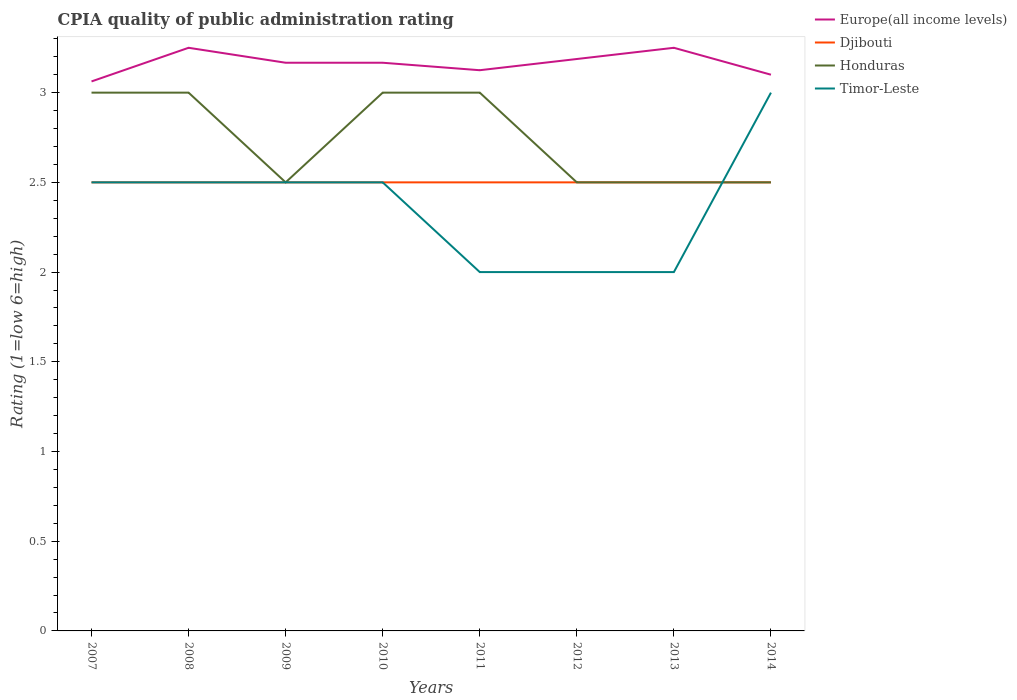How many different coloured lines are there?
Your response must be concise. 4. Is the number of lines equal to the number of legend labels?
Offer a terse response. Yes. Across all years, what is the maximum CPIA rating in Europe(all income levels)?
Offer a very short reply. 3.06. What is the difference between the highest and the second highest CPIA rating in Timor-Leste?
Offer a very short reply. 1. What is the difference between the highest and the lowest CPIA rating in Europe(all income levels)?
Make the answer very short. 5. Is the CPIA rating in Timor-Leste strictly greater than the CPIA rating in Europe(all income levels) over the years?
Offer a very short reply. Yes. How many lines are there?
Give a very brief answer. 4. How many years are there in the graph?
Provide a short and direct response. 8. What is the difference between two consecutive major ticks on the Y-axis?
Offer a very short reply. 0.5. Does the graph contain any zero values?
Make the answer very short. No. Does the graph contain grids?
Provide a succinct answer. No. How are the legend labels stacked?
Offer a terse response. Vertical. What is the title of the graph?
Make the answer very short. CPIA quality of public administration rating. What is the label or title of the X-axis?
Your response must be concise. Years. What is the Rating (1=low 6=high) in Europe(all income levels) in 2007?
Offer a very short reply. 3.06. What is the Rating (1=low 6=high) in Djibouti in 2007?
Ensure brevity in your answer.  2.5. What is the Rating (1=low 6=high) of Honduras in 2007?
Give a very brief answer. 3. What is the Rating (1=low 6=high) in Timor-Leste in 2007?
Your answer should be very brief. 2.5. What is the Rating (1=low 6=high) in Djibouti in 2008?
Provide a succinct answer. 2.5. What is the Rating (1=low 6=high) of Honduras in 2008?
Offer a very short reply. 3. What is the Rating (1=low 6=high) of Europe(all income levels) in 2009?
Ensure brevity in your answer.  3.17. What is the Rating (1=low 6=high) in Djibouti in 2009?
Your response must be concise. 2.5. What is the Rating (1=low 6=high) of Europe(all income levels) in 2010?
Your response must be concise. 3.17. What is the Rating (1=low 6=high) of Honduras in 2010?
Your answer should be very brief. 3. What is the Rating (1=low 6=high) of Timor-Leste in 2010?
Provide a succinct answer. 2.5. What is the Rating (1=low 6=high) in Europe(all income levels) in 2011?
Your answer should be very brief. 3.12. What is the Rating (1=low 6=high) of Djibouti in 2011?
Your response must be concise. 2.5. What is the Rating (1=low 6=high) of Honduras in 2011?
Provide a succinct answer. 3. What is the Rating (1=low 6=high) in Timor-Leste in 2011?
Give a very brief answer. 2. What is the Rating (1=low 6=high) of Europe(all income levels) in 2012?
Your answer should be compact. 3.19. What is the Rating (1=low 6=high) in Djibouti in 2012?
Offer a terse response. 2.5. What is the Rating (1=low 6=high) in Timor-Leste in 2014?
Your answer should be compact. 3. Across all years, what is the maximum Rating (1=low 6=high) of Djibouti?
Your response must be concise. 2.5. Across all years, what is the maximum Rating (1=low 6=high) in Timor-Leste?
Give a very brief answer. 3. Across all years, what is the minimum Rating (1=low 6=high) in Europe(all income levels)?
Your answer should be very brief. 3.06. Across all years, what is the minimum Rating (1=low 6=high) of Djibouti?
Your response must be concise. 2.5. Across all years, what is the minimum Rating (1=low 6=high) of Honduras?
Give a very brief answer. 2.5. Across all years, what is the minimum Rating (1=low 6=high) of Timor-Leste?
Your answer should be compact. 2. What is the total Rating (1=low 6=high) in Europe(all income levels) in the graph?
Offer a terse response. 25.31. What is the difference between the Rating (1=low 6=high) in Europe(all income levels) in 2007 and that in 2008?
Give a very brief answer. -0.19. What is the difference between the Rating (1=low 6=high) in Honduras in 2007 and that in 2008?
Give a very brief answer. 0. What is the difference between the Rating (1=low 6=high) of Timor-Leste in 2007 and that in 2008?
Your answer should be very brief. 0. What is the difference between the Rating (1=low 6=high) of Europe(all income levels) in 2007 and that in 2009?
Offer a terse response. -0.1. What is the difference between the Rating (1=low 6=high) of Djibouti in 2007 and that in 2009?
Keep it short and to the point. 0. What is the difference between the Rating (1=low 6=high) in Timor-Leste in 2007 and that in 2009?
Provide a short and direct response. 0. What is the difference between the Rating (1=low 6=high) in Europe(all income levels) in 2007 and that in 2010?
Offer a terse response. -0.1. What is the difference between the Rating (1=low 6=high) in Europe(all income levels) in 2007 and that in 2011?
Your response must be concise. -0.06. What is the difference between the Rating (1=low 6=high) in Europe(all income levels) in 2007 and that in 2012?
Your answer should be very brief. -0.12. What is the difference between the Rating (1=low 6=high) of Djibouti in 2007 and that in 2012?
Ensure brevity in your answer.  0. What is the difference between the Rating (1=low 6=high) in Europe(all income levels) in 2007 and that in 2013?
Offer a very short reply. -0.19. What is the difference between the Rating (1=low 6=high) in Timor-Leste in 2007 and that in 2013?
Your response must be concise. 0.5. What is the difference between the Rating (1=low 6=high) in Europe(all income levels) in 2007 and that in 2014?
Give a very brief answer. -0.04. What is the difference between the Rating (1=low 6=high) of Timor-Leste in 2007 and that in 2014?
Provide a succinct answer. -0.5. What is the difference between the Rating (1=low 6=high) of Europe(all income levels) in 2008 and that in 2009?
Offer a terse response. 0.08. What is the difference between the Rating (1=low 6=high) of Honduras in 2008 and that in 2009?
Provide a short and direct response. 0.5. What is the difference between the Rating (1=low 6=high) of Europe(all income levels) in 2008 and that in 2010?
Provide a succinct answer. 0.08. What is the difference between the Rating (1=low 6=high) in Honduras in 2008 and that in 2010?
Your answer should be very brief. 0. What is the difference between the Rating (1=low 6=high) of Timor-Leste in 2008 and that in 2010?
Offer a terse response. 0. What is the difference between the Rating (1=low 6=high) of Europe(all income levels) in 2008 and that in 2011?
Ensure brevity in your answer.  0.12. What is the difference between the Rating (1=low 6=high) in Europe(all income levels) in 2008 and that in 2012?
Offer a very short reply. 0.06. What is the difference between the Rating (1=low 6=high) of Honduras in 2008 and that in 2012?
Make the answer very short. 0.5. What is the difference between the Rating (1=low 6=high) in Timor-Leste in 2008 and that in 2012?
Keep it short and to the point. 0.5. What is the difference between the Rating (1=low 6=high) in Europe(all income levels) in 2008 and that in 2013?
Provide a succinct answer. 0. What is the difference between the Rating (1=low 6=high) of Djibouti in 2008 and that in 2014?
Your response must be concise. 0. What is the difference between the Rating (1=low 6=high) in Honduras in 2008 and that in 2014?
Your answer should be compact. 0.5. What is the difference between the Rating (1=low 6=high) in Honduras in 2009 and that in 2010?
Keep it short and to the point. -0.5. What is the difference between the Rating (1=low 6=high) of Europe(all income levels) in 2009 and that in 2011?
Give a very brief answer. 0.04. What is the difference between the Rating (1=low 6=high) of Honduras in 2009 and that in 2011?
Offer a very short reply. -0.5. What is the difference between the Rating (1=low 6=high) of Timor-Leste in 2009 and that in 2011?
Provide a succinct answer. 0.5. What is the difference between the Rating (1=low 6=high) in Europe(all income levels) in 2009 and that in 2012?
Provide a short and direct response. -0.02. What is the difference between the Rating (1=low 6=high) of Timor-Leste in 2009 and that in 2012?
Give a very brief answer. 0.5. What is the difference between the Rating (1=low 6=high) in Europe(all income levels) in 2009 and that in 2013?
Offer a terse response. -0.08. What is the difference between the Rating (1=low 6=high) of Timor-Leste in 2009 and that in 2013?
Offer a very short reply. 0.5. What is the difference between the Rating (1=low 6=high) in Europe(all income levels) in 2009 and that in 2014?
Give a very brief answer. 0.07. What is the difference between the Rating (1=low 6=high) in Djibouti in 2009 and that in 2014?
Offer a terse response. 0. What is the difference between the Rating (1=low 6=high) of Europe(all income levels) in 2010 and that in 2011?
Provide a short and direct response. 0.04. What is the difference between the Rating (1=low 6=high) in Honduras in 2010 and that in 2011?
Your answer should be very brief. 0. What is the difference between the Rating (1=low 6=high) in Timor-Leste in 2010 and that in 2011?
Keep it short and to the point. 0.5. What is the difference between the Rating (1=low 6=high) in Europe(all income levels) in 2010 and that in 2012?
Your answer should be compact. -0.02. What is the difference between the Rating (1=low 6=high) of Djibouti in 2010 and that in 2012?
Provide a short and direct response. 0. What is the difference between the Rating (1=low 6=high) in Europe(all income levels) in 2010 and that in 2013?
Keep it short and to the point. -0.08. What is the difference between the Rating (1=low 6=high) in Djibouti in 2010 and that in 2013?
Your answer should be very brief. 0. What is the difference between the Rating (1=low 6=high) of Honduras in 2010 and that in 2013?
Your answer should be very brief. 0.5. What is the difference between the Rating (1=low 6=high) in Europe(all income levels) in 2010 and that in 2014?
Your answer should be compact. 0.07. What is the difference between the Rating (1=low 6=high) of Djibouti in 2010 and that in 2014?
Your answer should be very brief. 0. What is the difference between the Rating (1=low 6=high) in Timor-Leste in 2010 and that in 2014?
Give a very brief answer. -0.5. What is the difference between the Rating (1=low 6=high) of Europe(all income levels) in 2011 and that in 2012?
Provide a short and direct response. -0.06. What is the difference between the Rating (1=low 6=high) of Djibouti in 2011 and that in 2012?
Your response must be concise. 0. What is the difference between the Rating (1=low 6=high) in Timor-Leste in 2011 and that in 2012?
Your response must be concise. 0. What is the difference between the Rating (1=low 6=high) of Europe(all income levels) in 2011 and that in 2013?
Your answer should be compact. -0.12. What is the difference between the Rating (1=low 6=high) in Timor-Leste in 2011 and that in 2013?
Your answer should be very brief. 0. What is the difference between the Rating (1=low 6=high) in Europe(all income levels) in 2011 and that in 2014?
Offer a very short reply. 0.03. What is the difference between the Rating (1=low 6=high) in Djibouti in 2011 and that in 2014?
Your answer should be compact. 0. What is the difference between the Rating (1=low 6=high) of Honduras in 2011 and that in 2014?
Your answer should be compact. 0.5. What is the difference between the Rating (1=low 6=high) of Timor-Leste in 2011 and that in 2014?
Keep it short and to the point. -1. What is the difference between the Rating (1=low 6=high) of Europe(all income levels) in 2012 and that in 2013?
Give a very brief answer. -0.06. What is the difference between the Rating (1=low 6=high) of Timor-Leste in 2012 and that in 2013?
Keep it short and to the point. 0. What is the difference between the Rating (1=low 6=high) in Europe(all income levels) in 2012 and that in 2014?
Provide a succinct answer. 0.09. What is the difference between the Rating (1=low 6=high) of Djibouti in 2012 and that in 2014?
Give a very brief answer. 0. What is the difference between the Rating (1=low 6=high) of Honduras in 2013 and that in 2014?
Ensure brevity in your answer.  0. What is the difference between the Rating (1=low 6=high) of Timor-Leste in 2013 and that in 2014?
Your response must be concise. -1. What is the difference between the Rating (1=low 6=high) of Europe(all income levels) in 2007 and the Rating (1=low 6=high) of Djibouti in 2008?
Provide a short and direct response. 0.56. What is the difference between the Rating (1=low 6=high) in Europe(all income levels) in 2007 and the Rating (1=low 6=high) in Honduras in 2008?
Ensure brevity in your answer.  0.06. What is the difference between the Rating (1=low 6=high) of Europe(all income levels) in 2007 and the Rating (1=low 6=high) of Timor-Leste in 2008?
Offer a terse response. 0.56. What is the difference between the Rating (1=low 6=high) of Honduras in 2007 and the Rating (1=low 6=high) of Timor-Leste in 2008?
Offer a terse response. 0.5. What is the difference between the Rating (1=low 6=high) in Europe(all income levels) in 2007 and the Rating (1=low 6=high) in Djibouti in 2009?
Offer a very short reply. 0.56. What is the difference between the Rating (1=low 6=high) of Europe(all income levels) in 2007 and the Rating (1=low 6=high) of Honduras in 2009?
Your answer should be compact. 0.56. What is the difference between the Rating (1=low 6=high) of Europe(all income levels) in 2007 and the Rating (1=low 6=high) of Timor-Leste in 2009?
Keep it short and to the point. 0.56. What is the difference between the Rating (1=low 6=high) in Honduras in 2007 and the Rating (1=low 6=high) in Timor-Leste in 2009?
Offer a terse response. 0.5. What is the difference between the Rating (1=low 6=high) of Europe(all income levels) in 2007 and the Rating (1=low 6=high) of Djibouti in 2010?
Offer a terse response. 0.56. What is the difference between the Rating (1=low 6=high) of Europe(all income levels) in 2007 and the Rating (1=low 6=high) of Honduras in 2010?
Give a very brief answer. 0.06. What is the difference between the Rating (1=low 6=high) in Europe(all income levels) in 2007 and the Rating (1=low 6=high) in Timor-Leste in 2010?
Offer a very short reply. 0.56. What is the difference between the Rating (1=low 6=high) of Djibouti in 2007 and the Rating (1=low 6=high) of Honduras in 2010?
Offer a very short reply. -0.5. What is the difference between the Rating (1=low 6=high) in Europe(all income levels) in 2007 and the Rating (1=low 6=high) in Djibouti in 2011?
Keep it short and to the point. 0.56. What is the difference between the Rating (1=low 6=high) of Europe(all income levels) in 2007 and the Rating (1=low 6=high) of Honduras in 2011?
Make the answer very short. 0.06. What is the difference between the Rating (1=low 6=high) in Europe(all income levels) in 2007 and the Rating (1=low 6=high) in Timor-Leste in 2011?
Keep it short and to the point. 1.06. What is the difference between the Rating (1=low 6=high) in Djibouti in 2007 and the Rating (1=low 6=high) in Timor-Leste in 2011?
Keep it short and to the point. 0.5. What is the difference between the Rating (1=low 6=high) of Honduras in 2007 and the Rating (1=low 6=high) of Timor-Leste in 2011?
Offer a terse response. 1. What is the difference between the Rating (1=low 6=high) of Europe(all income levels) in 2007 and the Rating (1=low 6=high) of Djibouti in 2012?
Your answer should be compact. 0.56. What is the difference between the Rating (1=low 6=high) in Europe(all income levels) in 2007 and the Rating (1=low 6=high) in Honduras in 2012?
Give a very brief answer. 0.56. What is the difference between the Rating (1=low 6=high) in Europe(all income levels) in 2007 and the Rating (1=low 6=high) in Timor-Leste in 2012?
Offer a terse response. 1.06. What is the difference between the Rating (1=low 6=high) in Djibouti in 2007 and the Rating (1=low 6=high) in Honduras in 2012?
Offer a very short reply. 0. What is the difference between the Rating (1=low 6=high) in Europe(all income levels) in 2007 and the Rating (1=low 6=high) in Djibouti in 2013?
Your response must be concise. 0.56. What is the difference between the Rating (1=low 6=high) in Europe(all income levels) in 2007 and the Rating (1=low 6=high) in Honduras in 2013?
Provide a short and direct response. 0.56. What is the difference between the Rating (1=low 6=high) in Djibouti in 2007 and the Rating (1=low 6=high) in Honduras in 2013?
Give a very brief answer. 0. What is the difference between the Rating (1=low 6=high) in Djibouti in 2007 and the Rating (1=low 6=high) in Timor-Leste in 2013?
Your answer should be very brief. 0.5. What is the difference between the Rating (1=low 6=high) of Europe(all income levels) in 2007 and the Rating (1=low 6=high) of Djibouti in 2014?
Your answer should be compact. 0.56. What is the difference between the Rating (1=low 6=high) of Europe(all income levels) in 2007 and the Rating (1=low 6=high) of Honduras in 2014?
Offer a very short reply. 0.56. What is the difference between the Rating (1=low 6=high) of Europe(all income levels) in 2007 and the Rating (1=low 6=high) of Timor-Leste in 2014?
Your answer should be very brief. 0.06. What is the difference between the Rating (1=low 6=high) in Honduras in 2007 and the Rating (1=low 6=high) in Timor-Leste in 2014?
Your response must be concise. 0. What is the difference between the Rating (1=low 6=high) in Europe(all income levels) in 2008 and the Rating (1=low 6=high) in Honduras in 2009?
Ensure brevity in your answer.  0.75. What is the difference between the Rating (1=low 6=high) of Europe(all income levels) in 2008 and the Rating (1=low 6=high) of Timor-Leste in 2009?
Provide a succinct answer. 0.75. What is the difference between the Rating (1=low 6=high) of Europe(all income levels) in 2008 and the Rating (1=low 6=high) of Djibouti in 2010?
Make the answer very short. 0.75. What is the difference between the Rating (1=low 6=high) of Djibouti in 2008 and the Rating (1=low 6=high) of Timor-Leste in 2010?
Your answer should be compact. 0. What is the difference between the Rating (1=low 6=high) of Honduras in 2008 and the Rating (1=low 6=high) of Timor-Leste in 2010?
Offer a terse response. 0.5. What is the difference between the Rating (1=low 6=high) in Europe(all income levels) in 2008 and the Rating (1=low 6=high) in Djibouti in 2011?
Ensure brevity in your answer.  0.75. What is the difference between the Rating (1=low 6=high) in Europe(all income levels) in 2008 and the Rating (1=low 6=high) in Djibouti in 2012?
Give a very brief answer. 0.75. What is the difference between the Rating (1=low 6=high) in Europe(all income levels) in 2008 and the Rating (1=low 6=high) in Honduras in 2012?
Provide a short and direct response. 0.75. What is the difference between the Rating (1=low 6=high) of Djibouti in 2008 and the Rating (1=low 6=high) of Honduras in 2012?
Offer a terse response. 0. What is the difference between the Rating (1=low 6=high) of Europe(all income levels) in 2008 and the Rating (1=low 6=high) of Djibouti in 2013?
Make the answer very short. 0.75. What is the difference between the Rating (1=low 6=high) of Europe(all income levels) in 2008 and the Rating (1=low 6=high) of Honduras in 2013?
Your response must be concise. 0.75. What is the difference between the Rating (1=low 6=high) of Europe(all income levels) in 2008 and the Rating (1=low 6=high) of Timor-Leste in 2013?
Offer a very short reply. 1.25. What is the difference between the Rating (1=low 6=high) in Europe(all income levels) in 2008 and the Rating (1=low 6=high) in Djibouti in 2014?
Your answer should be very brief. 0.75. What is the difference between the Rating (1=low 6=high) of Europe(all income levels) in 2008 and the Rating (1=low 6=high) of Timor-Leste in 2014?
Keep it short and to the point. 0.25. What is the difference between the Rating (1=low 6=high) in Honduras in 2008 and the Rating (1=low 6=high) in Timor-Leste in 2014?
Offer a terse response. 0. What is the difference between the Rating (1=low 6=high) of Europe(all income levels) in 2009 and the Rating (1=low 6=high) of Honduras in 2010?
Your response must be concise. 0.17. What is the difference between the Rating (1=low 6=high) in Djibouti in 2009 and the Rating (1=low 6=high) in Honduras in 2011?
Provide a short and direct response. -0.5. What is the difference between the Rating (1=low 6=high) in Djibouti in 2009 and the Rating (1=low 6=high) in Timor-Leste in 2011?
Provide a succinct answer. 0.5. What is the difference between the Rating (1=low 6=high) of Europe(all income levels) in 2009 and the Rating (1=low 6=high) of Honduras in 2012?
Your answer should be compact. 0.67. What is the difference between the Rating (1=low 6=high) of Djibouti in 2009 and the Rating (1=low 6=high) of Honduras in 2012?
Offer a very short reply. 0. What is the difference between the Rating (1=low 6=high) of Europe(all income levels) in 2009 and the Rating (1=low 6=high) of Djibouti in 2013?
Make the answer very short. 0.67. What is the difference between the Rating (1=low 6=high) of Europe(all income levels) in 2009 and the Rating (1=low 6=high) of Honduras in 2013?
Keep it short and to the point. 0.67. What is the difference between the Rating (1=low 6=high) of Europe(all income levels) in 2009 and the Rating (1=low 6=high) of Timor-Leste in 2013?
Your answer should be compact. 1.17. What is the difference between the Rating (1=low 6=high) of Djibouti in 2009 and the Rating (1=low 6=high) of Honduras in 2013?
Give a very brief answer. 0. What is the difference between the Rating (1=low 6=high) in Europe(all income levels) in 2009 and the Rating (1=low 6=high) in Honduras in 2014?
Your answer should be very brief. 0.67. What is the difference between the Rating (1=low 6=high) in Djibouti in 2009 and the Rating (1=low 6=high) in Honduras in 2014?
Make the answer very short. 0. What is the difference between the Rating (1=low 6=high) in Djibouti in 2009 and the Rating (1=low 6=high) in Timor-Leste in 2014?
Give a very brief answer. -0.5. What is the difference between the Rating (1=low 6=high) of Europe(all income levels) in 2010 and the Rating (1=low 6=high) of Timor-Leste in 2011?
Make the answer very short. 1.17. What is the difference between the Rating (1=low 6=high) of Djibouti in 2010 and the Rating (1=low 6=high) of Honduras in 2011?
Keep it short and to the point. -0.5. What is the difference between the Rating (1=low 6=high) of Djibouti in 2010 and the Rating (1=low 6=high) of Timor-Leste in 2011?
Ensure brevity in your answer.  0.5. What is the difference between the Rating (1=low 6=high) in Honduras in 2010 and the Rating (1=low 6=high) in Timor-Leste in 2011?
Offer a terse response. 1. What is the difference between the Rating (1=low 6=high) in Europe(all income levels) in 2010 and the Rating (1=low 6=high) in Honduras in 2012?
Your response must be concise. 0.67. What is the difference between the Rating (1=low 6=high) of Europe(all income levels) in 2010 and the Rating (1=low 6=high) of Timor-Leste in 2012?
Give a very brief answer. 1.17. What is the difference between the Rating (1=low 6=high) in Djibouti in 2010 and the Rating (1=low 6=high) in Timor-Leste in 2012?
Your response must be concise. 0.5. What is the difference between the Rating (1=low 6=high) of Honduras in 2010 and the Rating (1=low 6=high) of Timor-Leste in 2012?
Ensure brevity in your answer.  1. What is the difference between the Rating (1=low 6=high) of Europe(all income levels) in 2010 and the Rating (1=low 6=high) of Timor-Leste in 2013?
Your response must be concise. 1.17. What is the difference between the Rating (1=low 6=high) in Djibouti in 2010 and the Rating (1=low 6=high) in Honduras in 2013?
Provide a succinct answer. 0. What is the difference between the Rating (1=low 6=high) in Europe(all income levels) in 2010 and the Rating (1=low 6=high) in Djibouti in 2014?
Provide a succinct answer. 0.67. What is the difference between the Rating (1=low 6=high) in Europe(all income levels) in 2011 and the Rating (1=low 6=high) in Djibouti in 2012?
Offer a very short reply. 0.62. What is the difference between the Rating (1=low 6=high) in Honduras in 2011 and the Rating (1=low 6=high) in Timor-Leste in 2012?
Make the answer very short. 1. What is the difference between the Rating (1=low 6=high) in Europe(all income levels) in 2011 and the Rating (1=low 6=high) in Timor-Leste in 2013?
Make the answer very short. 1.12. What is the difference between the Rating (1=low 6=high) in Honduras in 2011 and the Rating (1=low 6=high) in Timor-Leste in 2013?
Provide a short and direct response. 1. What is the difference between the Rating (1=low 6=high) of Europe(all income levels) in 2011 and the Rating (1=low 6=high) of Djibouti in 2014?
Offer a terse response. 0.62. What is the difference between the Rating (1=low 6=high) in Europe(all income levels) in 2011 and the Rating (1=low 6=high) in Honduras in 2014?
Give a very brief answer. 0.62. What is the difference between the Rating (1=low 6=high) in Honduras in 2011 and the Rating (1=low 6=high) in Timor-Leste in 2014?
Offer a very short reply. 0. What is the difference between the Rating (1=low 6=high) in Europe(all income levels) in 2012 and the Rating (1=low 6=high) in Djibouti in 2013?
Provide a short and direct response. 0.69. What is the difference between the Rating (1=low 6=high) in Europe(all income levels) in 2012 and the Rating (1=low 6=high) in Honduras in 2013?
Make the answer very short. 0.69. What is the difference between the Rating (1=low 6=high) of Europe(all income levels) in 2012 and the Rating (1=low 6=high) of Timor-Leste in 2013?
Make the answer very short. 1.19. What is the difference between the Rating (1=low 6=high) in Honduras in 2012 and the Rating (1=low 6=high) in Timor-Leste in 2013?
Ensure brevity in your answer.  0.5. What is the difference between the Rating (1=low 6=high) of Europe(all income levels) in 2012 and the Rating (1=low 6=high) of Djibouti in 2014?
Offer a terse response. 0.69. What is the difference between the Rating (1=low 6=high) in Europe(all income levels) in 2012 and the Rating (1=low 6=high) in Honduras in 2014?
Provide a short and direct response. 0.69. What is the difference between the Rating (1=low 6=high) of Europe(all income levels) in 2012 and the Rating (1=low 6=high) of Timor-Leste in 2014?
Offer a very short reply. 0.19. What is the difference between the Rating (1=low 6=high) in Djibouti in 2012 and the Rating (1=low 6=high) in Honduras in 2014?
Your response must be concise. 0. What is the difference between the Rating (1=low 6=high) of Honduras in 2012 and the Rating (1=low 6=high) of Timor-Leste in 2014?
Provide a succinct answer. -0.5. What is the average Rating (1=low 6=high) in Europe(all income levels) per year?
Offer a terse response. 3.16. What is the average Rating (1=low 6=high) in Djibouti per year?
Provide a succinct answer. 2.5. What is the average Rating (1=low 6=high) in Honduras per year?
Your answer should be compact. 2.75. What is the average Rating (1=low 6=high) in Timor-Leste per year?
Give a very brief answer. 2.38. In the year 2007, what is the difference between the Rating (1=low 6=high) in Europe(all income levels) and Rating (1=low 6=high) in Djibouti?
Your response must be concise. 0.56. In the year 2007, what is the difference between the Rating (1=low 6=high) in Europe(all income levels) and Rating (1=low 6=high) in Honduras?
Provide a short and direct response. 0.06. In the year 2007, what is the difference between the Rating (1=low 6=high) of Europe(all income levels) and Rating (1=low 6=high) of Timor-Leste?
Your response must be concise. 0.56. In the year 2007, what is the difference between the Rating (1=low 6=high) in Djibouti and Rating (1=low 6=high) in Honduras?
Keep it short and to the point. -0.5. In the year 2008, what is the difference between the Rating (1=low 6=high) of Europe(all income levels) and Rating (1=low 6=high) of Timor-Leste?
Your answer should be very brief. 0.75. In the year 2008, what is the difference between the Rating (1=low 6=high) in Djibouti and Rating (1=low 6=high) in Honduras?
Your answer should be compact. -0.5. In the year 2008, what is the difference between the Rating (1=low 6=high) of Djibouti and Rating (1=low 6=high) of Timor-Leste?
Give a very brief answer. 0. In the year 2009, what is the difference between the Rating (1=low 6=high) of Europe(all income levels) and Rating (1=low 6=high) of Djibouti?
Offer a very short reply. 0.67. In the year 2009, what is the difference between the Rating (1=low 6=high) of Djibouti and Rating (1=low 6=high) of Timor-Leste?
Provide a succinct answer. 0. In the year 2009, what is the difference between the Rating (1=low 6=high) in Honduras and Rating (1=low 6=high) in Timor-Leste?
Your answer should be very brief. 0. In the year 2010, what is the difference between the Rating (1=low 6=high) of Djibouti and Rating (1=low 6=high) of Timor-Leste?
Your answer should be compact. 0. In the year 2011, what is the difference between the Rating (1=low 6=high) in Europe(all income levels) and Rating (1=low 6=high) in Honduras?
Your answer should be compact. 0.12. In the year 2011, what is the difference between the Rating (1=low 6=high) of Europe(all income levels) and Rating (1=low 6=high) of Timor-Leste?
Provide a short and direct response. 1.12. In the year 2012, what is the difference between the Rating (1=low 6=high) in Europe(all income levels) and Rating (1=low 6=high) in Djibouti?
Make the answer very short. 0.69. In the year 2012, what is the difference between the Rating (1=low 6=high) in Europe(all income levels) and Rating (1=low 6=high) in Honduras?
Offer a very short reply. 0.69. In the year 2012, what is the difference between the Rating (1=low 6=high) in Europe(all income levels) and Rating (1=low 6=high) in Timor-Leste?
Provide a short and direct response. 1.19. In the year 2012, what is the difference between the Rating (1=low 6=high) in Djibouti and Rating (1=low 6=high) in Honduras?
Provide a short and direct response. 0. In the year 2013, what is the difference between the Rating (1=low 6=high) of Europe(all income levels) and Rating (1=low 6=high) of Djibouti?
Offer a terse response. 0.75. In the year 2013, what is the difference between the Rating (1=low 6=high) in Europe(all income levels) and Rating (1=low 6=high) in Honduras?
Your response must be concise. 0.75. In the year 2014, what is the difference between the Rating (1=low 6=high) of Djibouti and Rating (1=low 6=high) of Honduras?
Your response must be concise. 0. In the year 2014, what is the difference between the Rating (1=low 6=high) in Djibouti and Rating (1=low 6=high) in Timor-Leste?
Your answer should be compact. -0.5. What is the ratio of the Rating (1=low 6=high) in Europe(all income levels) in 2007 to that in 2008?
Provide a short and direct response. 0.94. What is the ratio of the Rating (1=low 6=high) in Djibouti in 2007 to that in 2008?
Your answer should be very brief. 1. What is the ratio of the Rating (1=low 6=high) of Timor-Leste in 2007 to that in 2008?
Offer a very short reply. 1. What is the ratio of the Rating (1=low 6=high) in Europe(all income levels) in 2007 to that in 2009?
Your answer should be very brief. 0.97. What is the ratio of the Rating (1=low 6=high) in Djibouti in 2007 to that in 2009?
Your answer should be very brief. 1. What is the ratio of the Rating (1=low 6=high) in Honduras in 2007 to that in 2009?
Ensure brevity in your answer.  1.2. What is the ratio of the Rating (1=low 6=high) of Europe(all income levels) in 2007 to that in 2010?
Provide a succinct answer. 0.97. What is the ratio of the Rating (1=low 6=high) in Europe(all income levels) in 2007 to that in 2011?
Your response must be concise. 0.98. What is the ratio of the Rating (1=low 6=high) of Djibouti in 2007 to that in 2011?
Keep it short and to the point. 1. What is the ratio of the Rating (1=low 6=high) of Europe(all income levels) in 2007 to that in 2012?
Give a very brief answer. 0.96. What is the ratio of the Rating (1=low 6=high) in Djibouti in 2007 to that in 2012?
Your answer should be very brief. 1. What is the ratio of the Rating (1=low 6=high) in Honduras in 2007 to that in 2012?
Your answer should be very brief. 1.2. What is the ratio of the Rating (1=low 6=high) in Europe(all income levels) in 2007 to that in 2013?
Provide a short and direct response. 0.94. What is the ratio of the Rating (1=low 6=high) in Djibouti in 2007 to that in 2013?
Offer a terse response. 1. What is the ratio of the Rating (1=low 6=high) of Timor-Leste in 2007 to that in 2013?
Provide a short and direct response. 1.25. What is the ratio of the Rating (1=low 6=high) of Europe(all income levels) in 2007 to that in 2014?
Ensure brevity in your answer.  0.99. What is the ratio of the Rating (1=low 6=high) of Timor-Leste in 2007 to that in 2014?
Your answer should be very brief. 0.83. What is the ratio of the Rating (1=low 6=high) of Europe(all income levels) in 2008 to that in 2009?
Make the answer very short. 1.03. What is the ratio of the Rating (1=low 6=high) in Djibouti in 2008 to that in 2009?
Provide a succinct answer. 1. What is the ratio of the Rating (1=low 6=high) in Honduras in 2008 to that in 2009?
Your answer should be compact. 1.2. What is the ratio of the Rating (1=low 6=high) of Timor-Leste in 2008 to that in 2009?
Ensure brevity in your answer.  1. What is the ratio of the Rating (1=low 6=high) in Europe(all income levels) in 2008 to that in 2010?
Your answer should be very brief. 1.03. What is the ratio of the Rating (1=low 6=high) in Honduras in 2008 to that in 2010?
Give a very brief answer. 1. What is the ratio of the Rating (1=low 6=high) in Timor-Leste in 2008 to that in 2010?
Your answer should be compact. 1. What is the ratio of the Rating (1=low 6=high) in Timor-Leste in 2008 to that in 2011?
Provide a short and direct response. 1.25. What is the ratio of the Rating (1=low 6=high) in Europe(all income levels) in 2008 to that in 2012?
Your answer should be very brief. 1.02. What is the ratio of the Rating (1=low 6=high) of Djibouti in 2008 to that in 2012?
Provide a succinct answer. 1. What is the ratio of the Rating (1=low 6=high) of Europe(all income levels) in 2008 to that in 2013?
Keep it short and to the point. 1. What is the ratio of the Rating (1=low 6=high) of Djibouti in 2008 to that in 2013?
Your response must be concise. 1. What is the ratio of the Rating (1=low 6=high) in Honduras in 2008 to that in 2013?
Your response must be concise. 1.2. What is the ratio of the Rating (1=low 6=high) of Europe(all income levels) in 2008 to that in 2014?
Your answer should be very brief. 1.05. What is the ratio of the Rating (1=low 6=high) of Djibouti in 2008 to that in 2014?
Make the answer very short. 1. What is the ratio of the Rating (1=low 6=high) of Europe(all income levels) in 2009 to that in 2010?
Make the answer very short. 1. What is the ratio of the Rating (1=low 6=high) of Djibouti in 2009 to that in 2010?
Offer a very short reply. 1. What is the ratio of the Rating (1=low 6=high) in Honduras in 2009 to that in 2010?
Offer a very short reply. 0.83. What is the ratio of the Rating (1=low 6=high) in Europe(all income levels) in 2009 to that in 2011?
Provide a succinct answer. 1.01. What is the ratio of the Rating (1=low 6=high) of Honduras in 2009 to that in 2011?
Give a very brief answer. 0.83. What is the ratio of the Rating (1=low 6=high) in Timor-Leste in 2009 to that in 2011?
Offer a very short reply. 1.25. What is the ratio of the Rating (1=low 6=high) in Europe(all income levels) in 2009 to that in 2013?
Give a very brief answer. 0.97. What is the ratio of the Rating (1=low 6=high) of Djibouti in 2009 to that in 2013?
Provide a short and direct response. 1. What is the ratio of the Rating (1=low 6=high) in Timor-Leste in 2009 to that in 2013?
Make the answer very short. 1.25. What is the ratio of the Rating (1=low 6=high) in Europe(all income levels) in 2009 to that in 2014?
Your response must be concise. 1.02. What is the ratio of the Rating (1=low 6=high) of Honduras in 2009 to that in 2014?
Your response must be concise. 1. What is the ratio of the Rating (1=low 6=high) of Timor-Leste in 2009 to that in 2014?
Offer a very short reply. 0.83. What is the ratio of the Rating (1=low 6=high) of Europe(all income levels) in 2010 to that in 2011?
Offer a terse response. 1.01. What is the ratio of the Rating (1=low 6=high) in Honduras in 2010 to that in 2011?
Give a very brief answer. 1. What is the ratio of the Rating (1=low 6=high) in Europe(all income levels) in 2010 to that in 2012?
Your answer should be compact. 0.99. What is the ratio of the Rating (1=low 6=high) in Timor-Leste in 2010 to that in 2012?
Provide a succinct answer. 1.25. What is the ratio of the Rating (1=low 6=high) of Europe(all income levels) in 2010 to that in 2013?
Provide a short and direct response. 0.97. What is the ratio of the Rating (1=low 6=high) of Djibouti in 2010 to that in 2013?
Make the answer very short. 1. What is the ratio of the Rating (1=low 6=high) of Timor-Leste in 2010 to that in 2013?
Provide a short and direct response. 1.25. What is the ratio of the Rating (1=low 6=high) in Europe(all income levels) in 2010 to that in 2014?
Keep it short and to the point. 1.02. What is the ratio of the Rating (1=low 6=high) of Djibouti in 2010 to that in 2014?
Provide a succinct answer. 1. What is the ratio of the Rating (1=low 6=high) of Timor-Leste in 2010 to that in 2014?
Your answer should be compact. 0.83. What is the ratio of the Rating (1=low 6=high) of Europe(all income levels) in 2011 to that in 2012?
Your answer should be compact. 0.98. What is the ratio of the Rating (1=low 6=high) of Timor-Leste in 2011 to that in 2012?
Your answer should be very brief. 1. What is the ratio of the Rating (1=low 6=high) in Europe(all income levels) in 2011 to that in 2013?
Your response must be concise. 0.96. What is the ratio of the Rating (1=low 6=high) of Timor-Leste in 2011 to that in 2013?
Provide a succinct answer. 1. What is the ratio of the Rating (1=low 6=high) in Europe(all income levels) in 2011 to that in 2014?
Give a very brief answer. 1.01. What is the ratio of the Rating (1=low 6=high) in Djibouti in 2011 to that in 2014?
Make the answer very short. 1. What is the ratio of the Rating (1=low 6=high) of Honduras in 2011 to that in 2014?
Provide a short and direct response. 1.2. What is the ratio of the Rating (1=low 6=high) of Timor-Leste in 2011 to that in 2014?
Make the answer very short. 0.67. What is the ratio of the Rating (1=low 6=high) in Europe(all income levels) in 2012 to that in 2013?
Offer a terse response. 0.98. What is the ratio of the Rating (1=low 6=high) of Honduras in 2012 to that in 2013?
Provide a short and direct response. 1. What is the ratio of the Rating (1=low 6=high) of Timor-Leste in 2012 to that in 2013?
Keep it short and to the point. 1. What is the ratio of the Rating (1=low 6=high) in Europe(all income levels) in 2012 to that in 2014?
Offer a very short reply. 1.03. What is the ratio of the Rating (1=low 6=high) of Djibouti in 2012 to that in 2014?
Ensure brevity in your answer.  1. What is the ratio of the Rating (1=low 6=high) of Timor-Leste in 2012 to that in 2014?
Give a very brief answer. 0.67. What is the ratio of the Rating (1=low 6=high) of Europe(all income levels) in 2013 to that in 2014?
Keep it short and to the point. 1.05. What is the ratio of the Rating (1=low 6=high) of Honduras in 2013 to that in 2014?
Keep it short and to the point. 1. What is the ratio of the Rating (1=low 6=high) of Timor-Leste in 2013 to that in 2014?
Your answer should be very brief. 0.67. What is the difference between the highest and the second highest Rating (1=low 6=high) of Honduras?
Provide a short and direct response. 0. What is the difference between the highest and the lowest Rating (1=low 6=high) in Europe(all income levels)?
Your answer should be compact. 0.19. What is the difference between the highest and the lowest Rating (1=low 6=high) in Honduras?
Make the answer very short. 0.5. 